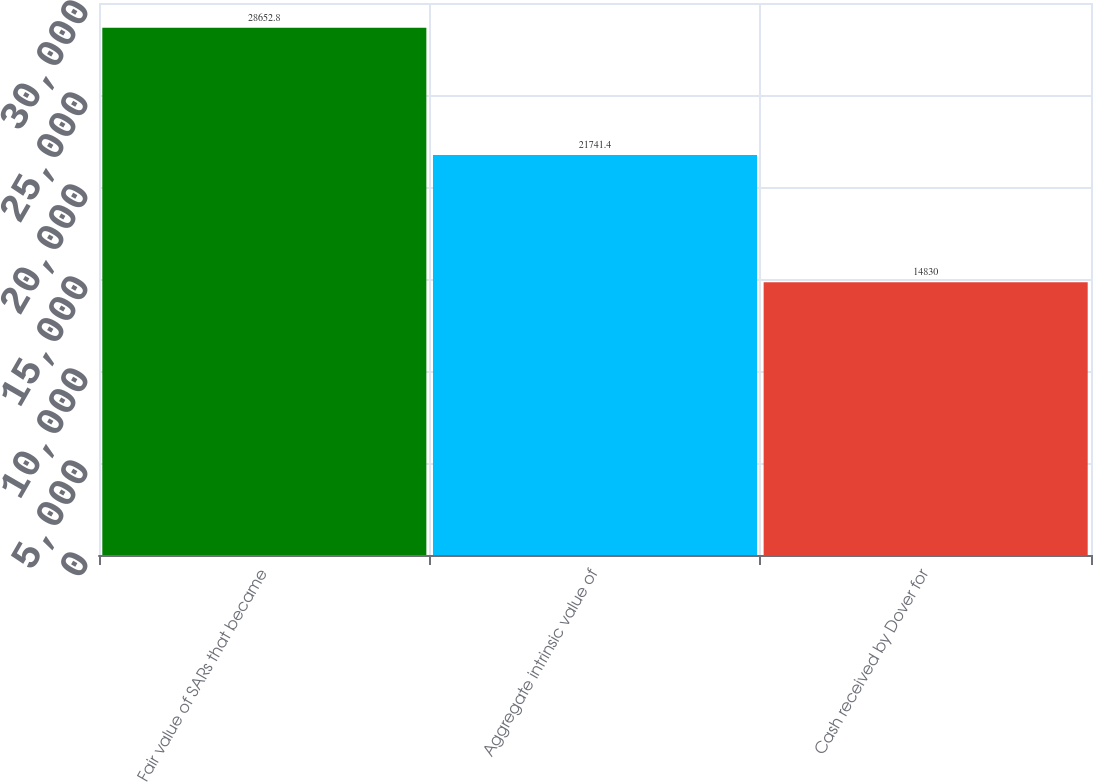Convert chart to OTSL. <chart><loc_0><loc_0><loc_500><loc_500><bar_chart><fcel>Fair value of SARs that became<fcel>Aggregate intrinsic value of<fcel>Cash received by Dover for<nl><fcel>28652.8<fcel>21741.4<fcel>14830<nl></chart> 